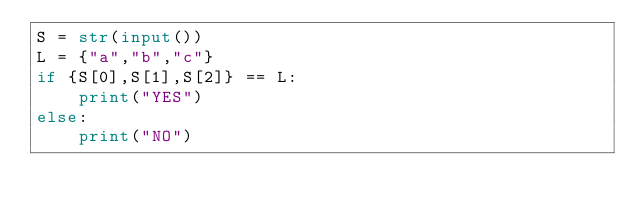<code> <loc_0><loc_0><loc_500><loc_500><_Python_>S = str(input())
L = {"a","b","c"}
if {S[0],S[1],S[2]} == L:
    print("YES")
else:
    print("NO")
</code> 